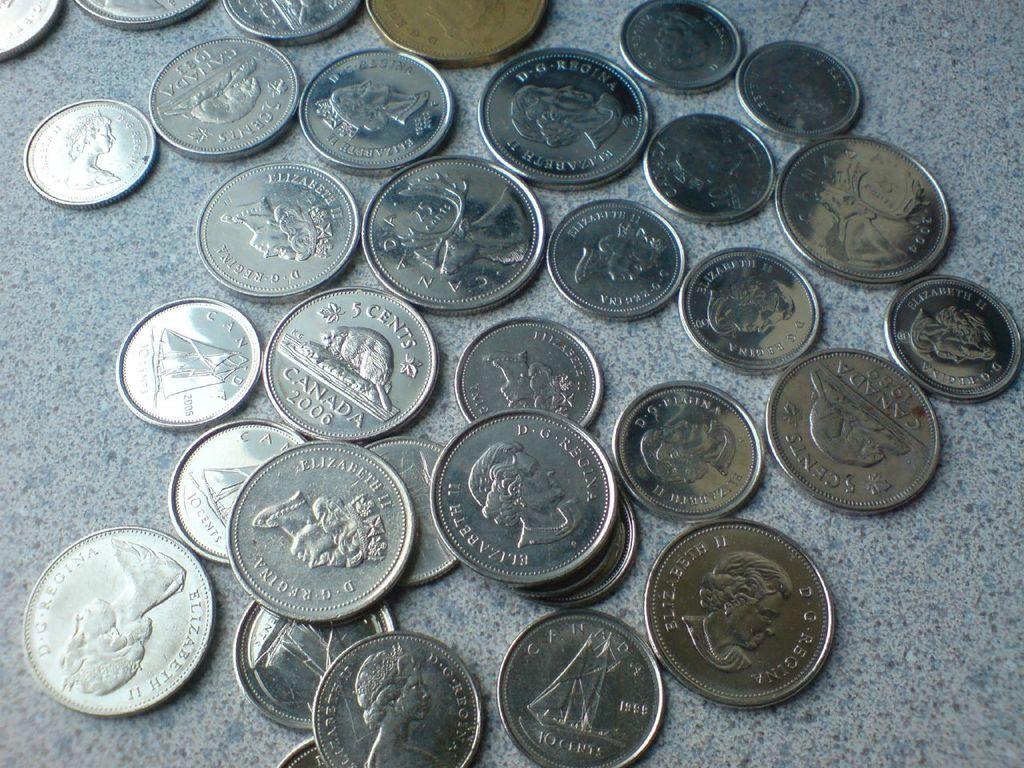What is the value of one of these coins?
Ensure brevity in your answer.  5 cents. What year is the 5 cent piece?
Keep it short and to the point. 2006. 